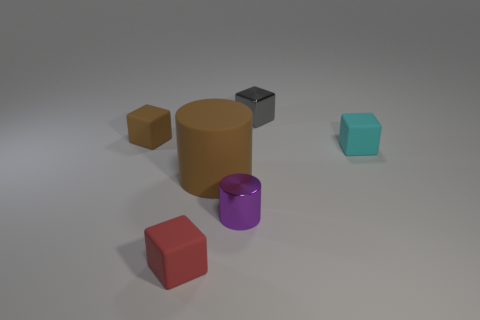Subtract all small metal blocks. How many blocks are left? 3 Subtract all red blocks. How many blocks are left? 3 Add 3 tiny rubber objects. How many objects exist? 9 Subtract all blue cubes. Subtract all blue balls. How many cubes are left? 4 Subtract all cylinders. How many objects are left? 4 Subtract 1 brown cubes. How many objects are left? 5 Subtract all big brown shiny spheres. Subtract all small purple metallic cylinders. How many objects are left? 5 Add 6 metal cylinders. How many metal cylinders are left? 7 Add 4 cubes. How many cubes exist? 8 